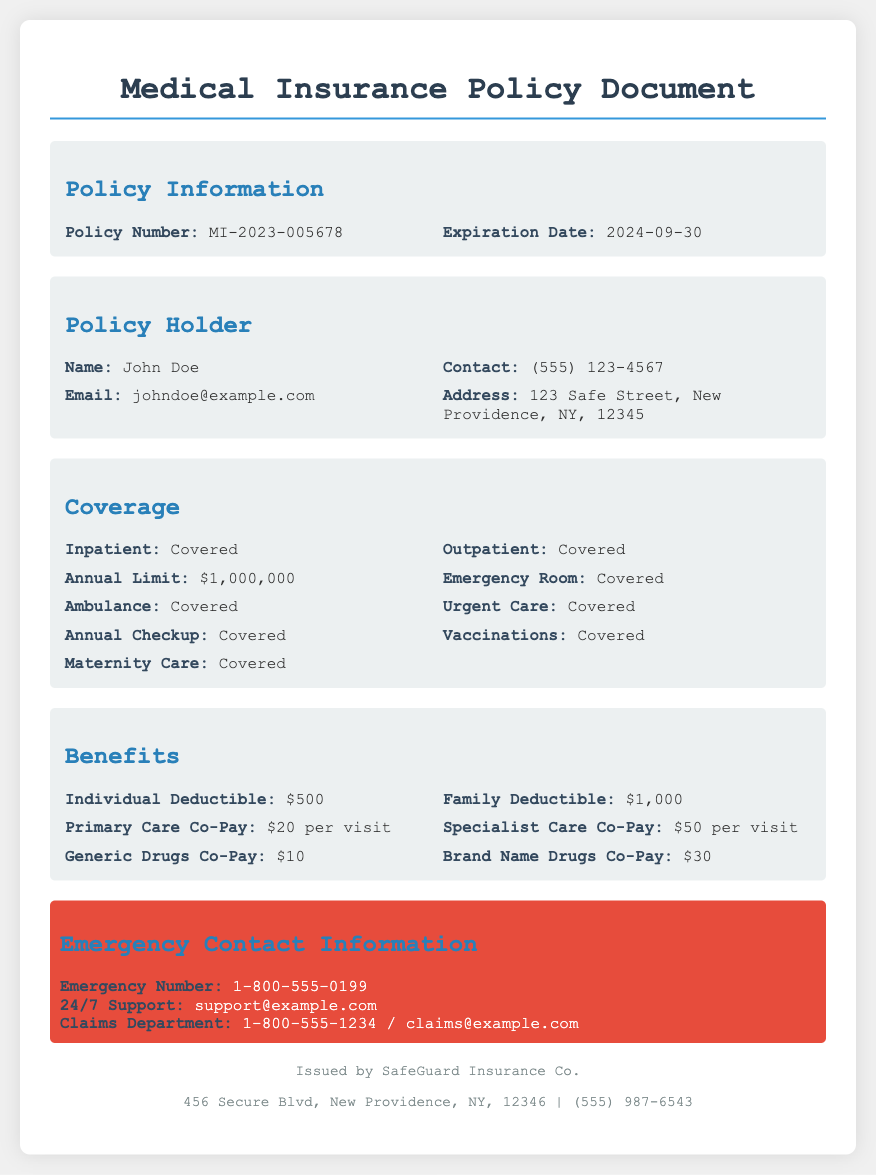What is the policy number? The policy number is listed in the Policy Information section as MI-2023-005678.
Answer: MI-2023-005678 What is the expiration date of the policy? The expiration date can be found in the Policy Information section and is stated as 2024-09-30.
Answer: 2024-09-30 Who is the policy holder? The name of the policy holder is mentioned in the Policy Holder section as John Doe.
Answer: John Doe What is the individual deductible? The individual deductible is provided in the Benefits section and is listed as $500.
Answer: $500 What is covered under outpatient care? The document states that outpatient care is covered in the Coverage section, indicating the general inclusion of such services.
Answer: Covered How much is the primary care co-pay? The primary care co-pay can be found in the Benefits section, where it is indicated as $20 per visit.
Answer: $20 per visit What is the emergency contact number? The emergency contact number is provided in the Emergency Contact Information section as 1-800-555-0199.
Answer: 1-800-555-0199 What is the total annual limit for coverage? The total annual limit is listed in the Coverage section as $1,000,000, indicating the maximum amount covered annually.
Answer: $1,000,000 Which company issued this policy document? The issuing company is mentioned in the footer of the document as SafeGuard Insurance Co.
Answer: SafeGuard Insurance Co What support is available 24/7? The document specifies that 24/7 support can be reached via email at support@example.com, indicating constant availability for assistance.
Answer: support@example.com 